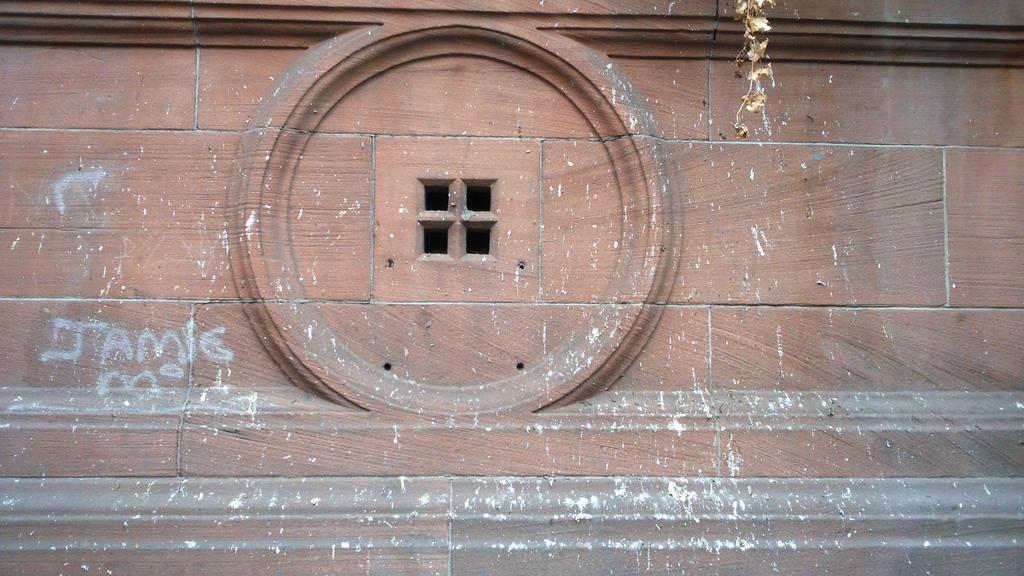What is the main structure visible in the image? There is a building in the image. Are there any words or letters on the building? Yes, there are letters written on the building. Can you see any openings in the building? There is a window visible in the image. What type of metal can be seen being cut by scissors in the image? There are no scissors or metal present in the image; it only features a building with letters and a window. 